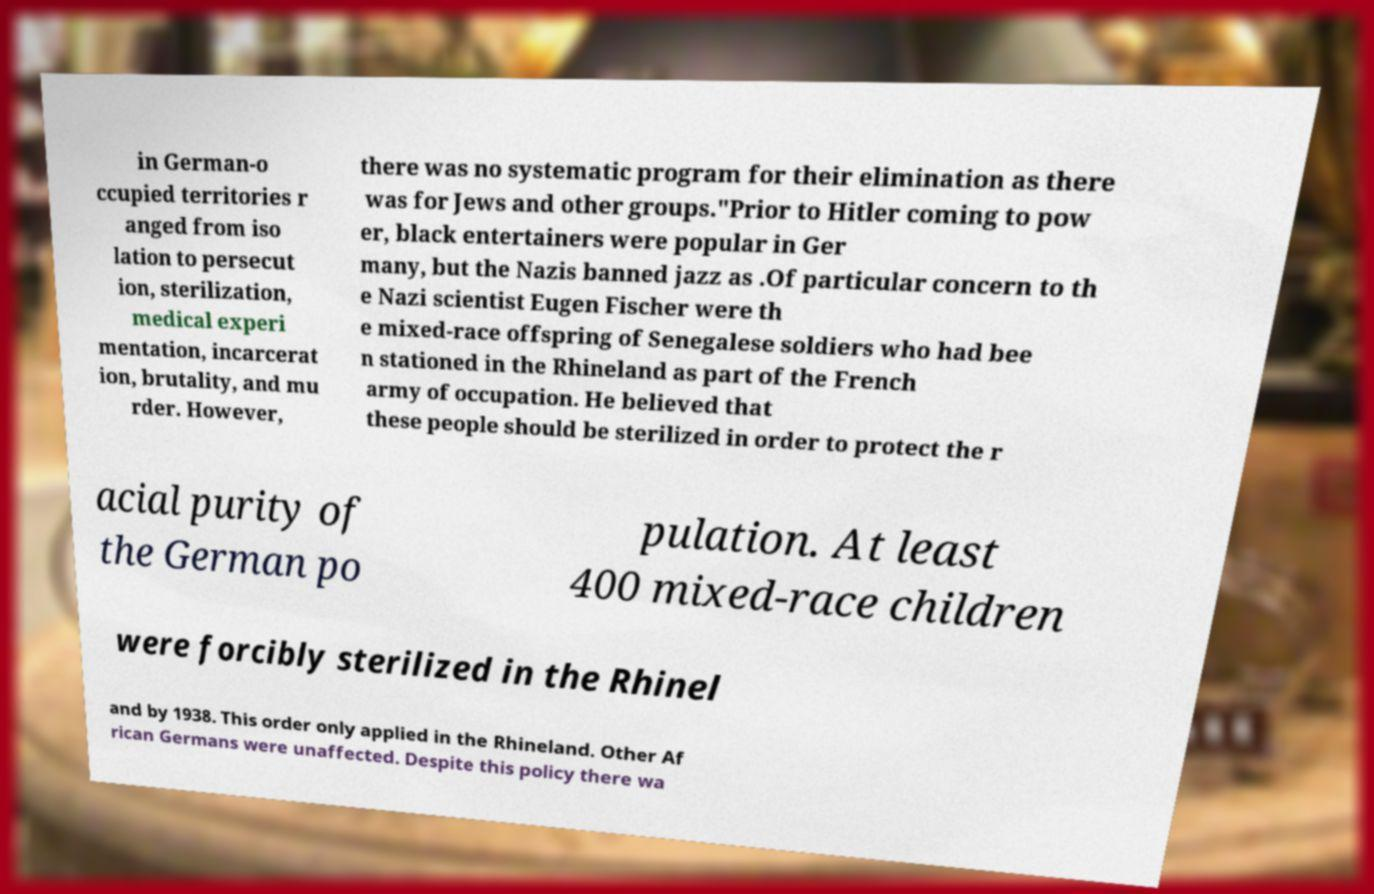Can you accurately transcribe the text from the provided image for me? in German-o ccupied territories r anged from iso lation to persecut ion, sterilization, medical experi mentation, incarcerat ion, brutality, and mu rder. However, there was no systematic program for their elimination as there was for Jews and other groups."Prior to Hitler coming to pow er, black entertainers were popular in Ger many, but the Nazis banned jazz as .Of particular concern to th e Nazi scientist Eugen Fischer were th e mixed-race offspring of Senegalese soldiers who had bee n stationed in the Rhineland as part of the French army of occupation. He believed that these people should be sterilized in order to protect the r acial purity of the German po pulation. At least 400 mixed-race children were forcibly sterilized in the Rhinel and by 1938. This order only applied in the Rhineland. Other Af rican Germans were unaffected. Despite this policy there wa 